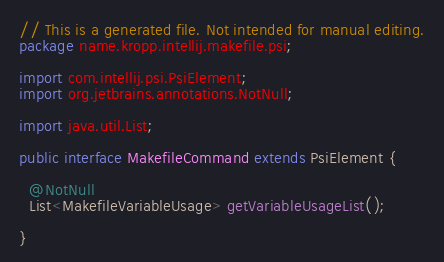<code> <loc_0><loc_0><loc_500><loc_500><_Java_>// This is a generated file. Not intended for manual editing.
package name.kropp.intellij.makefile.psi;

import com.intellij.psi.PsiElement;
import org.jetbrains.annotations.NotNull;

import java.util.List;

public interface MakefileCommand extends PsiElement {

  @NotNull
  List<MakefileVariableUsage> getVariableUsageList();

}
</code> 